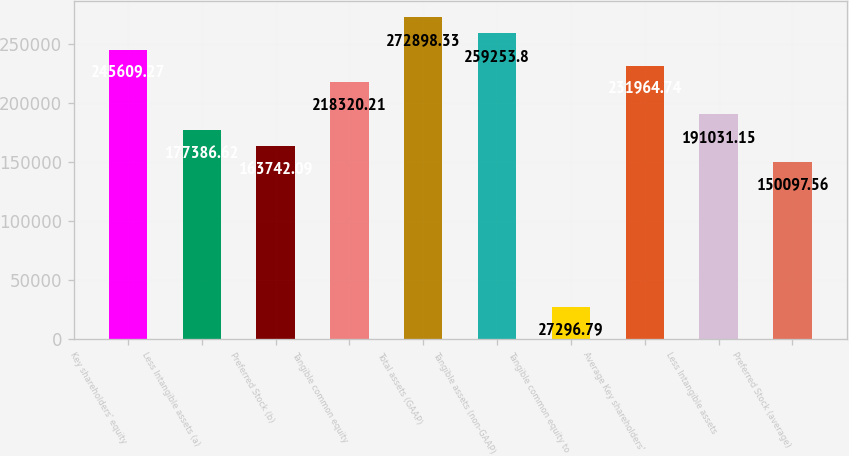Convert chart to OTSL. <chart><loc_0><loc_0><loc_500><loc_500><bar_chart><fcel>Key shareholders' equity<fcel>Less Intangible assets (a)<fcel>Preferred Stock (b)<fcel>Tangible common equity<fcel>Total assets (GAAP)<fcel>Tangible assets (non-GAAP)<fcel>Tangible common equity to<fcel>Average Key shareholders'<fcel>Less Intangible assets<fcel>Preferred Stock (average)<nl><fcel>245609<fcel>177387<fcel>163742<fcel>218320<fcel>272898<fcel>259254<fcel>27296.8<fcel>231965<fcel>191031<fcel>150098<nl></chart> 